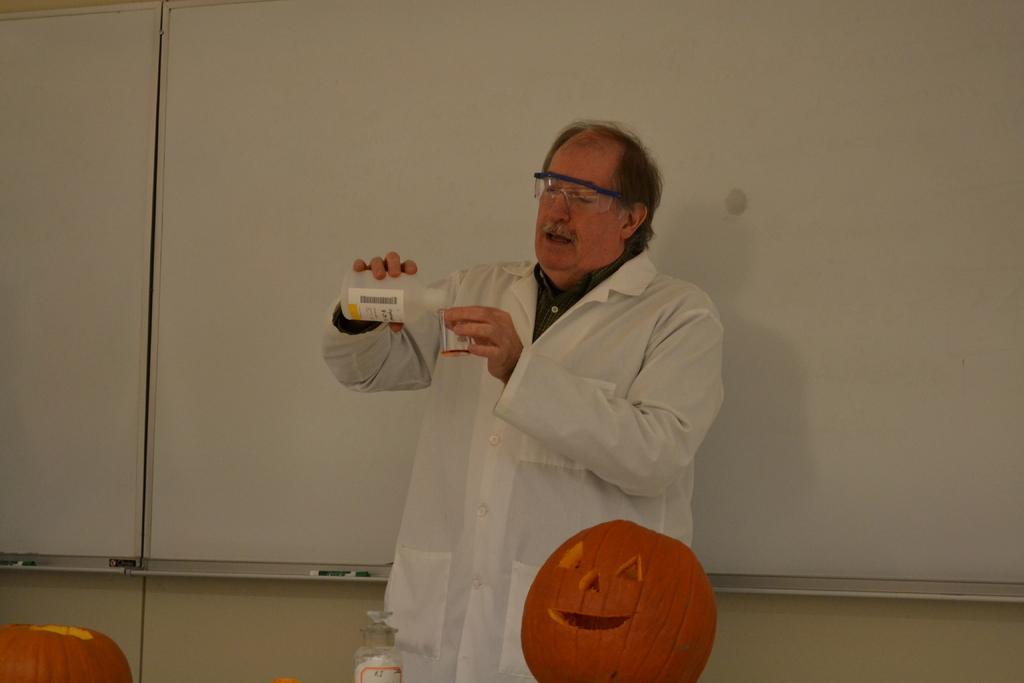Describe this image in one or two sentences. In this picture we can see an old man wearing a white apron and glasses showing a chemistry experiment to someone. 